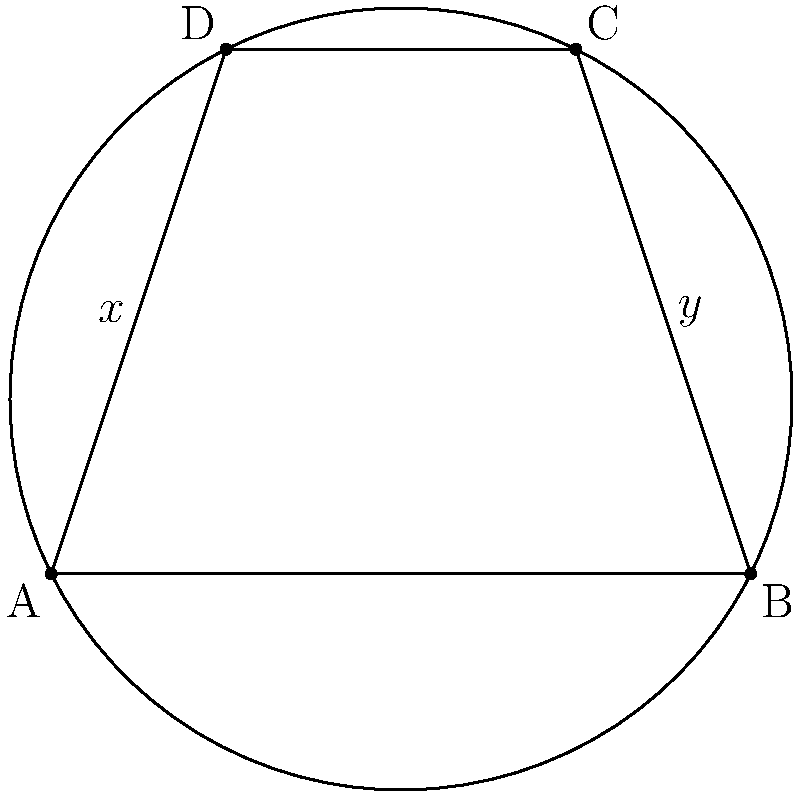In the cyclic quadrilateral ABCD shown above, angles DAB and DCB are denoted as $x$ and $y$ respectively. Which of the following statements is true about the relationship between $x$ and $y$?

A) $x + y = 90°$
B) $x + y = 180°$
C) $x = y$
D) $x - y = 90°$ Let's approach this step-by-step:

1) In a cyclic quadrilateral, opposite angles are supplementary. This means that:
   $$\angle DAB + \angle BCD = 180°$$
   $$\angle ABC + \angle ADC = 180°$$

2) We are given that $\angle DAB = x$ and $\angle DCB = y$.

3) In the cyclic quadrilateral ABCD, $\angle BCD$ is the opposite angle to $\angle DAB$. Therefore:
   $$x + \angle BCD = 180°$$

4) $\angle DCB$ (which equals $y$) is an exterior angle of triangle BCD. An exterior angle of a triangle is equal to the sum of the two non-adjacent interior angles. So:
   $$y = \angle BCD + \angle CBD$$

5) From steps 3 and 4, we can deduce:
   $$x + y = 180°$$

This relationship holds true for any cyclic quadrilateral, regardless of its specific shape or size.
Answer: B) $x + y = 180°$ 